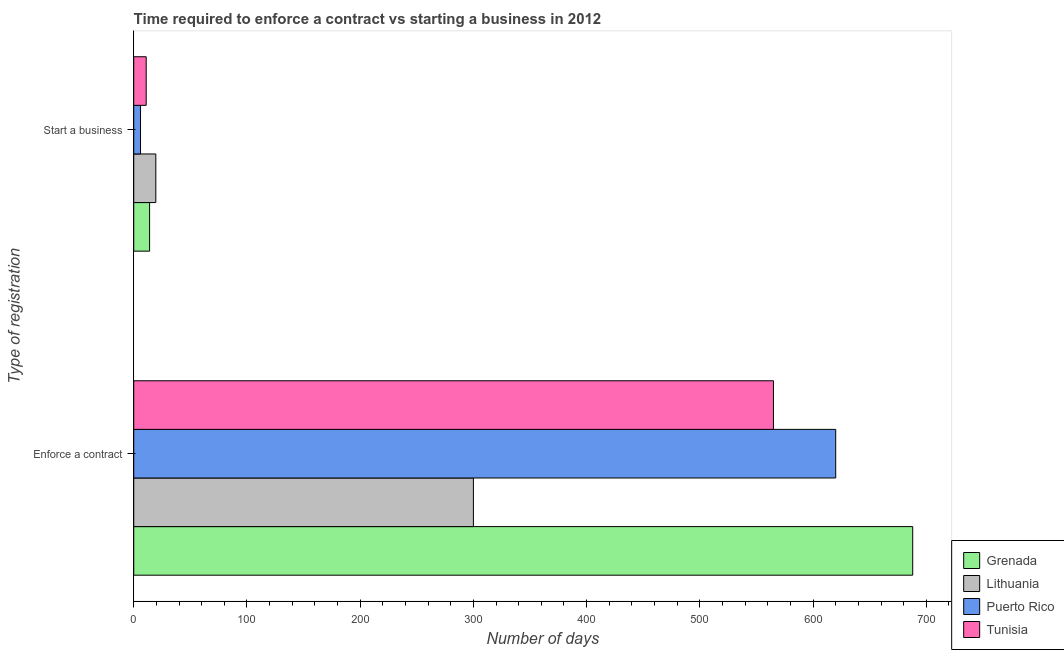How many different coloured bars are there?
Your answer should be compact. 4. Are the number of bars per tick equal to the number of legend labels?
Your answer should be compact. Yes. How many bars are there on the 2nd tick from the bottom?
Provide a succinct answer. 4. What is the label of the 1st group of bars from the top?
Your answer should be very brief. Start a business. Across all countries, what is the maximum number of days to enforece a contract?
Offer a terse response. 688. In which country was the number of days to enforece a contract maximum?
Provide a short and direct response. Grenada. In which country was the number of days to enforece a contract minimum?
Your response must be concise. Lithuania. What is the total number of days to enforece a contract in the graph?
Provide a succinct answer. 2173. What is the difference between the number of days to enforece a contract in Grenada and that in Puerto Rico?
Make the answer very short. 68. What is the difference between the number of days to start a business in Puerto Rico and the number of days to enforece a contract in Lithuania?
Your answer should be compact. -294. What is the average number of days to enforece a contract per country?
Make the answer very short. 543.25. What is the difference between the number of days to start a business and number of days to enforece a contract in Tunisia?
Offer a terse response. -554. In how many countries, is the number of days to enforece a contract greater than 540 days?
Keep it short and to the point. 3. What is the ratio of the number of days to start a business in Tunisia to that in Lithuania?
Provide a succinct answer. 0.56. What does the 3rd bar from the top in Start a business represents?
Offer a terse response. Lithuania. What does the 1st bar from the bottom in Enforce a contract represents?
Offer a terse response. Grenada. How many bars are there?
Give a very brief answer. 8. Are all the bars in the graph horizontal?
Offer a terse response. Yes. What is the difference between two consecutive major ticks on the X-axis?
Your answer should be compact. 100. Does the graph contain any zero values?
Your response must be concise. No. Does the graph contain grids?
Keep it short and to the point. No. Where does the legend appear in the graph?
Your answer should be very brief. Bottom right. How many legend labels are there?
Ensure brevity in your answer.  4. What is the title of the graph?
Offer a terse response. Time required to enforce a contract vs starting a business in 2012. Does "Ukraine" appear as one of the legend labels in the graph?
Provide a succinct answer. No. What is the label or title of the X-axis?
Your response must be concise. Number of days. What is the label or title of the Y-axis?
Your response must be concise. Type of registration. What is the Number of days of Grenada in Enforce a contract?
Give a very brief answer. 688. What is the Number of days in Lithuania in Enforce a contract?
Make the answer very short. 300. What is the Number of days in Puerto Rico in Enforce a contract?
Provide a short and direct response. 620. What is the Number of days in Tunisia in Enforce a contract?
Make the answer very short. 565. What is the Number of days of Grenada in Start a business?
Keep it short and to the point. 14. What is the Number of days in Tunisia in Start a business?
Provide a succinct answer. 11. Across all Type of registration, what is the maximum Number of days in Grenada?
Your answer should be very brief. 688. Across all Type of registration, what is the maximum Number of days in Lithuania?
Give a very brief answer. 300. Across all Type of registration, what is the maximum Number of days in Puerto Rico?
Your response must be concise. 620. Across all Type of registration, what is the maximum Number of days in Tunisia?
Your response must be concise. 565. Across all Type of registration, what is the minimum Number of days of Lithuania?
Offer a terse response. 19.5. Across all Type of registration, what is the minimum Number of days of Puerto Rico?
Offer a terse response. 6. What is the total Number of days in Grenada in the graph?
Ensure brevity in your answer.  702. What is the total Number of days of Lithuania in the graph?
Your response must be concise. 319.5. What is the total Number of days in Puerto Rico in the graph?
Provide a succinct answer. 626. What is the total Number of days in Tunisia in the graph?
Your answer should be compact. 576. What is the difference between the Number of days of Grenada in Enforce a contract and that in Start a business?
Provide a short and direct response. 674. What is the difference between the Number of days of Lithuania in Enforce a contract and that in Start a business?
Your response must be concise. 280.5. What is the difference between the Number of days in Puerto Rico in Enforce a contract and that in Start a business?
Provide a succinct answer. 614. What is the difference between the Number of days in Tunisia in Enforce a contract and that in Start a business?
Make the answer very short. 554. What is the difference between the Number of days of Grenada in Enforce a contract and the Number of days of Lithuania in Start a business?
Your response must be concise. 668.5. What is the difference between the Number of days in Grenada in Enforce a contract and the Number of days in Puerto Rico in Start a business?
Your answer should be very brief. 682. What is the difference between the Number of days in Grenada in Enforce a contract and the Number of days in Tunisia in Start a business?
Ensure brevity in your answer.  677. What is the difference between the Number of days in Lithuania in Enforce a contract and the Number of days in Puerto Rico in Start a business?
Provide a short and direct response. 294. What is the difference between the Number of days in Lithuania in Enforce a contract and the Number of days in Tunisia in Start a business?
Offer a very short reply. 289. What is the difference between the Number of days in Puerto Rico in Enforce a contract and the Number of days in Tunisia in Start a business?
Your answer should be very brief. 609. What is the average Number of days in Grenada per Type of registration?
Provide a short and direct response. 351. What is the average Number of days of Lithuania per Type of registration?
Offer a very short reply. 159.75. What is the average Number of days in Puerto Rico per Type of registration?
Your answer should be compact. 313. What is the average Number of days of Tunisia per Type of registration?
Offer a very short reply. 288. What is the difference between the Number of days in Grenada and Number of days in Lithuania in Enforce a contract?
Provide a succinct answer. 388. What is the difference between the Number of days in Grenada and Number of days in Tunisia in Enforce a contract?
Your answer should be very brief. 123. What is the difference between the Number of days in Lithuania and Number of days in Puerto Rico in Enforce a contract?
Ensure brevity in your answer.  -320. What is the difference between the Number of days of Lithuania and Number of days of Tunisia in Enforce a contract?
Provide a short and direct response. -265. What is the difference between the Number of days in Grenada and Number of days in Lithuania in Start a business?
Keep it short and to the point. -5.5. What is the difference between the Number of days in Grenada and Number of days in Tunisia in Start a business?
Your response must be concise. 3. What is the difference between the Number of days in Lithuania and Number of days in Puerto Rico in Start a business?
Provide a short and direct response. 13.5. What is the difference between the Number of days of Puerto Rico and Number of days of Tunisia in Start a business?
Give a very brief answer. -5. What is the ratio of the Number of days of Grenada in Enforce a contract to that in Start a business?
Keep it short and to the point. 49.14. What is the ratio of the Number of days in Lithuania in Enforce a contract to that in Start a business?
Your answer should be very brief. 15.38. What is the ratio of the Number of days in Puerto Rico in Enforce a contract to that in Start a business?
Your answer should be very brief. 103.33. What is the ratio of the Number of days of Tunisia in Enforce a contract to that in Start a business?
Provide a short and direct response. 51.36. What is the difference between the highest and the second highest Number of days of Grenada?
Ensure brevity in your answer.  674. What is the difference between the highest and the second highest Number of days in Lithuania?
Ensure brevity in your answer.  280.5. What is the difference between the highest and the second highest Number of days of Puerto Rico?
Keep it short and to the point. 614. What is the difference between the highest and the second highest Number of days in Tunisia?
Provide a succinct answer. 554. What is the difference between the highest and the lowest Number of days of Grenada?
Make the answer very short. 674. What is the difference between the highest and the lowest Number of days of Lithuania?
Provide a short and direct response. 280.5. What is the difference between the highest and the lowest Number of days of Puerto Rico?
Your answer should be compact. 614. What is the difference between the highest and the lowest Number of days of Tunisia?
Offer a very short reply. 554. 